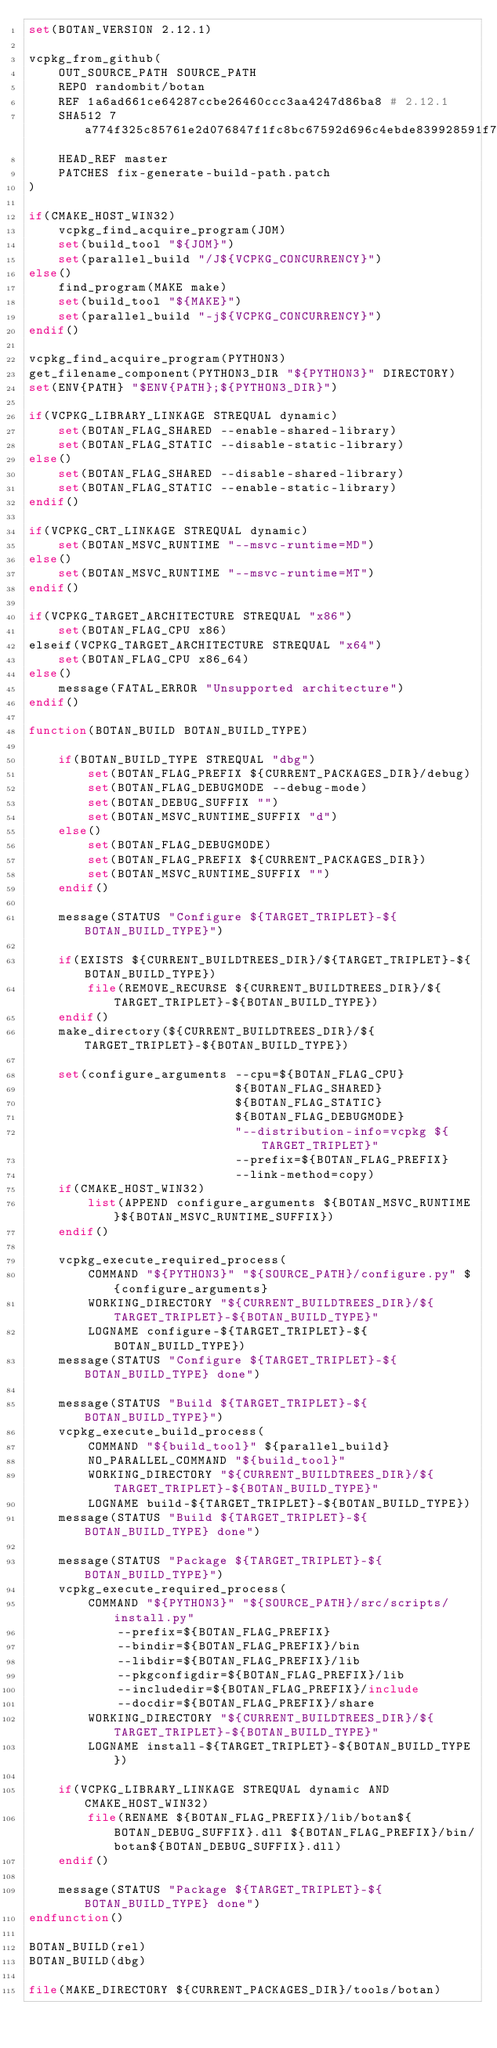Convert code to text. <code><loc_0><loc_0><loc_500><loc_500><_CMake_>set(BOTAN_VERSION 2.12.1)

vcpkg_from_github(
    OUT_SOURCE_PATH SOURCE_PATH
    REPO randombit/botan
    REF 1a6ad661ce64287ccbe26460ccc3aa4247d86ba8 # 2.12.1
    SHA512 7a774f325c85761e2d076847f1fc8bc67592d696c4ebde839928591f7c85352e2df6032c122bdcc603adf84d76f5a1897c7118aa3859d38f79e474f27bc3b588
    HEAD_REF master
    PATCHES fix-generate-build-path.patch
)

if(CMAKE_HOST_WIN32)
    vcpkg_find_acquire_program(JOM)
    set(build_tool "${JOM}")
    set(parallel_build "/J${VCPKG_CONCURRENCY}")
else()
    find_program(MAKE make)
    set(build_tool "${MAKE}")
    set(parallel_build "-j${VCPKG_CONCURRENCY}")
endif()

vcpkg_find_acquire_program(PYTHON3)
get_filename_component(PYTHON3_DIR "${PYTHON3}" DIRECTORY)
set(ENV{PATH} "$ENV{PATH};${PYTHON3_DIR}")

if(VCPKG_LIBRARY_LINKAGE STREQUAL dynamic)
    set(BOTAN_FLAG_SHARED --enable-shared-library)
    set(BOTAN_FLAG_STATIC --disable-static-library)
else()
    set(BOTAN_FLAG_SHARED --disable-shared-library)
    set(BOTAN_FLAG_STATIC --enable-static-library)
endif()

if(VCPKG_CRT_LINKAGE STREQUAL dynamic)
    set(BOTAN_MSVC_RUNTIME "--msvc-runtime=MD")
else()
    set(BOTAN_MSVC_RUNTIME "--msvc-runtime=MT")
endif()

if(VCPKG_TARGET_ARCHITECTURE STREQUAL "x86")
    set(BOTAN_FLAG_CPU x86)
elseif(VCPKG_TARGET_ARCHITECTURE STREQUAL "x64")
    set(BOTAN_FLAG_CPU x86_64)
else()
    message(FATAL_ERROR "Unsupported architecture")
endif()

function(BOTAN_BUILD BOTAN_BUILD_TYPE)

    if(BOTAN_BUILD_TYPE STREQUAL "dbg")
        set(BOTAN_FLAG_PREFIX ${CURRENT_PACKAGES_DIR}/debug)
        set(BOTAN_FLAG_DEBUGMODE --debug-mode)
        set(BOTAN_DEBUG_SUFFIX "")
        set(BOTAN_MSVC_RUNTIME_SUFFIX "d")
    else()
        set(BOTAN_FLAG_DEBUGMODE)
        set(BOTAN_FLAG_PREFIX ${CURRENT_PACKAGES_DIR})
        set(BOTAN_MSVC_RUNTIME_SUFFIX "")
    endif()

    message(STATUS "Configure ${TARGET_TRIPLET}-${BOTAN_BUILD_TYPE}")

    if(EXISTS ${CURRENT_BUILDTREES_DIR}/${TARGET_TRIPLET}-${BOTAN_BUILD_TYPE})
        file(REMOVE_RECURSE ${CURRENT_BUILDTREES_DIR}/${TARGET_TRIPLET}-${BOTAN_BUILD_TYPE})
    endif()
    make_directory(${CURRENT_BUILDTREES_DIR}/${TARGET_TRIPLET}-${BOTAN_BUILD_TYPE})

    set(configure_arguments --cpu=${BOTAN_FLAG_CPU}
                            ${BOTAN_FLAG_SHARED}
                            ${BOTAN_FLAG_STATIC}
                            ${BOTAN_FLAG_DEBUGMODE}
                            "--distribution-info=vcpkg ${TARGET_TRIPLET}"
                            --prefix=${BOTAN_FLAG_PREFIX}
                            --link-method=copy)
    if(CMAKE_HOST_WIN32)
        list(APPEND configure_arguments ${BOTAN_MSVC_RUNTIME}${BOTAN_MSVC_RUNTIME_SUFFIX})
    endif()

    vcpkg_execute_required_process(
        COMMAND "${PYTHON3}" "${SOURCE_PATH}/configure.py" ${configure_arguments}
        WORKING_DIRECTORY "${CURRENT_BUILDTREES_DIR}/${TARGET_TRIPLET}-${BOTAN_BUILD_TYPE}"
        LOGNAME configure-${TARGET_TRIPLET}-${BOTAN_BUILD_TYPE})
    message(STATUS "Configure ${TARGET_TRIPLET}-${BOTAN_BUILD_TYPE} done")

    message(STATUS "Build ${TARGET_TRIPLET}-${BOTAN_BUILD_TYPE}")
    vcpkg_execute_build_process(
        COMMAND "${build_tool}" ${parallel_build}
        NO_PARALLEL_COMMAND "${build_tool}"
        WORKING_DIRECTORY "${CURRENT_BUILDTREES_DIR}/${TARGET_TRIPLET}-${BOTAN_BUILD_TYPE}"
        LOGNAME build-${TARGET_TRIPLET}-${BOTAN_BUILD_TYPE})
    message(STATUS "Build ${TARGET_TRIPLET}-${BOTAN_BUILD_TYPE} done")

    message(STATUS "Package ${TARGET_TRIPLET}-${BOTAN_BUILD_TYPE}")
    vcpkg_execute_required_process(
        COMMAND "${PYTHON3}" "${SOURCE_PATH}/src/scripts/install.py"
            --prefix=${BOTAN_FLAG_PREFIX}
            --bindir=${BOTAN_FLAG_PREFIX}/bin
            --libdir=${BOTAN_FLAG_PREFIX}/lib
            --pkgconfigdir=${BOTAN_FLAG_PREFIX}/lib
            --includedir=${BOTAN_FLAG_PREFIX}/include
            --docdir=${BOTAN_FLAG_PREFIX}/share
        WORKING_DIRECTORY "${CURRENT_BUILDTREES_DIR}/${TARGET_TRIPLET}-${BOTAN_BUILD_TYPE}"
        LOGNAME install-${TARGET_TRIPLET}-${BOTAN_BUILD_TYPE})

    if(VCPKG_LIBRARY_LINKAGE STREQUAL dynamic AND CMAKE_HOST_WIN32)
        file(RENAME ${BOTAN_FLAG_PREFIX}/lib/botan${BOTAN_DEBUG_SUFFIX}.dll ${BOTAN_FLAG_PREFIX}/bin/botan${BOTAN_DEBUG_SUFFIX}.dll)
    endif()

    message(STATUS "Package ${TARGET_TRIPLET}-${BOTAN_BUILD_TYPE} done")
endfunction()

BOTAN_BUILD(rel)
BOTAN_BUILD(dbg)

file(MAKE_DIRECTORY ${CURRENT_PACKAGES_DIR}/tools/botan)
</code> 